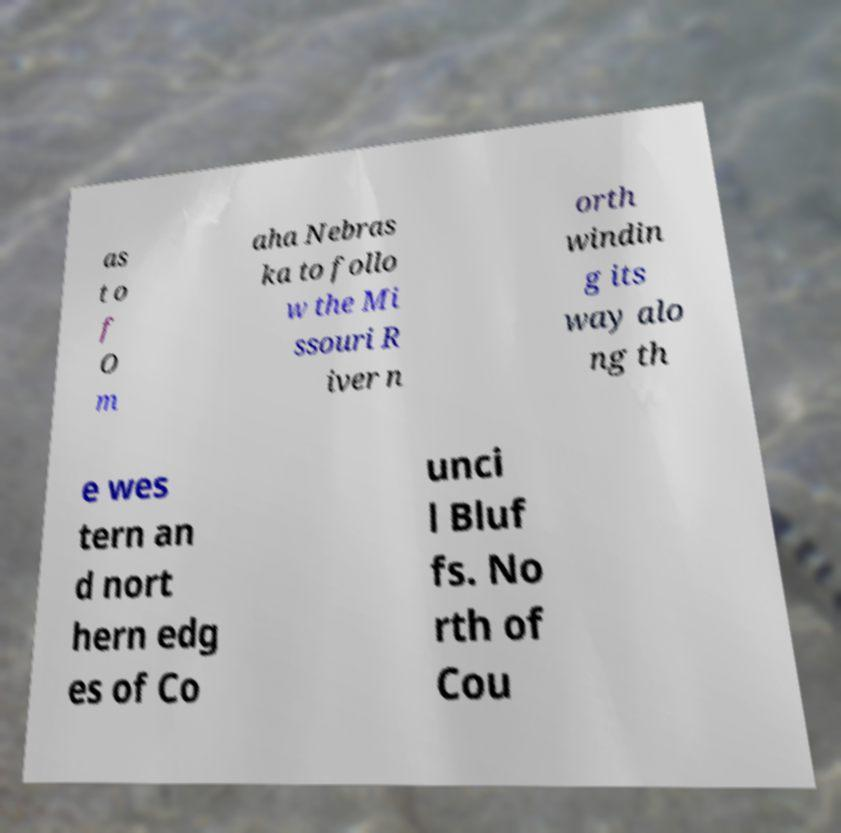For documentation purposes, I need the text within this image transcribed. Could you provide that? as t o f O m aha Nebras ka to follo w the Mi ssouri R iver n orth windin g its way alo ng th e wes tern an d nort hern edg es of Co unci l Bluf fs. No rth of Cou 